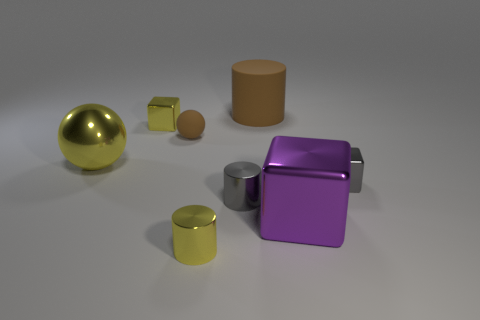Are there any other red objects that have the same shape as the small matte thing?
Your response must be concise. No. What color is the metallic cube right of the big shiny thing in front of the tiny gray shiny object that is to the right of the big rubber cylinder?
Your answer should be compact. Gray. What number of metal objects are tiny blue things or large spheres?
Give a very brief answer. 1. Are there more large spheres in front of the large yellow metallic ball than small metal objects on the right side of the small brown rubber sphere?
Keep it short and to the point. No. What number of other things are there of the same size as the yellow sphere?
Keep it short and to the point. 2. There is a block behind the gray metal thing to the right of the brown matte cylinder; what is its size?
Your answer should be compact. Small. How many small objects are either brown spheres or cyan balls?
Give a very brief answer. 1. How big is the metallic cylinder that is to the right of the small yellow object that is in front of the big object that is on the right side of the matte cylinder?
Your response must be concise. Small. Are there any other things that have the same color as the small matte ball?
Keep it short and to the point. Yes. The gray object that is on the right side of the rubber object that is on the right side of the tiny yellow shiny thing right of the yellow block is made of what material?
Make the answer very short. Metal. 